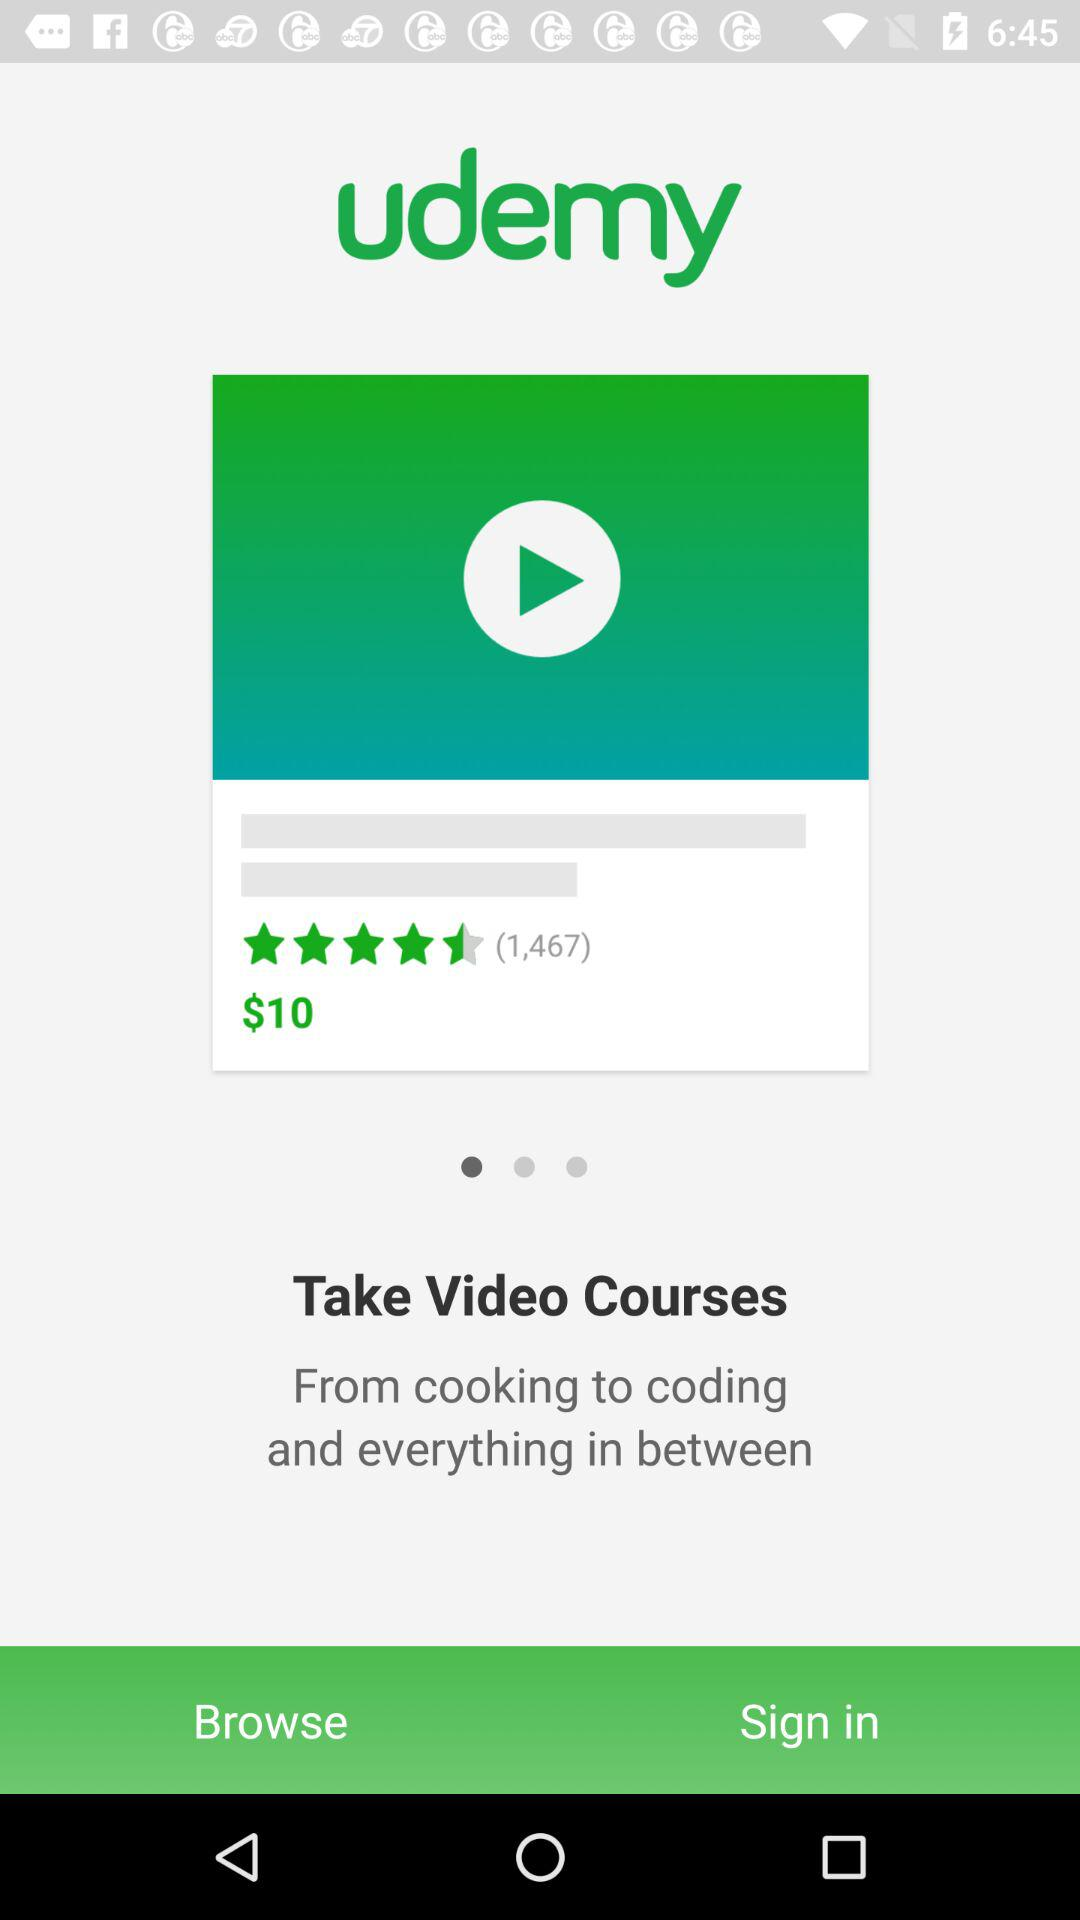What is the application name? The application name is "udemy". 